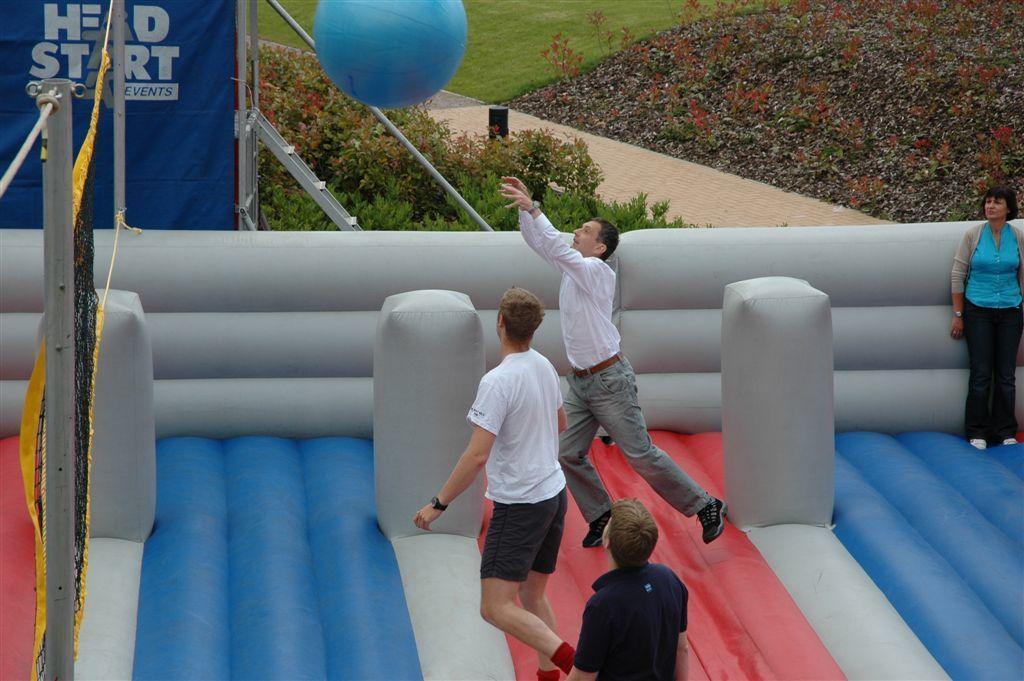Please provide a concise description of this image. In the image there is an inflatable and a group of people were playing with a ball inside the inflatable, around that there are many trees and grass. 